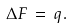<formula> <loc_0><loc_0><loc_500><loc_500>\Delta F \, = \, q .</formula> 